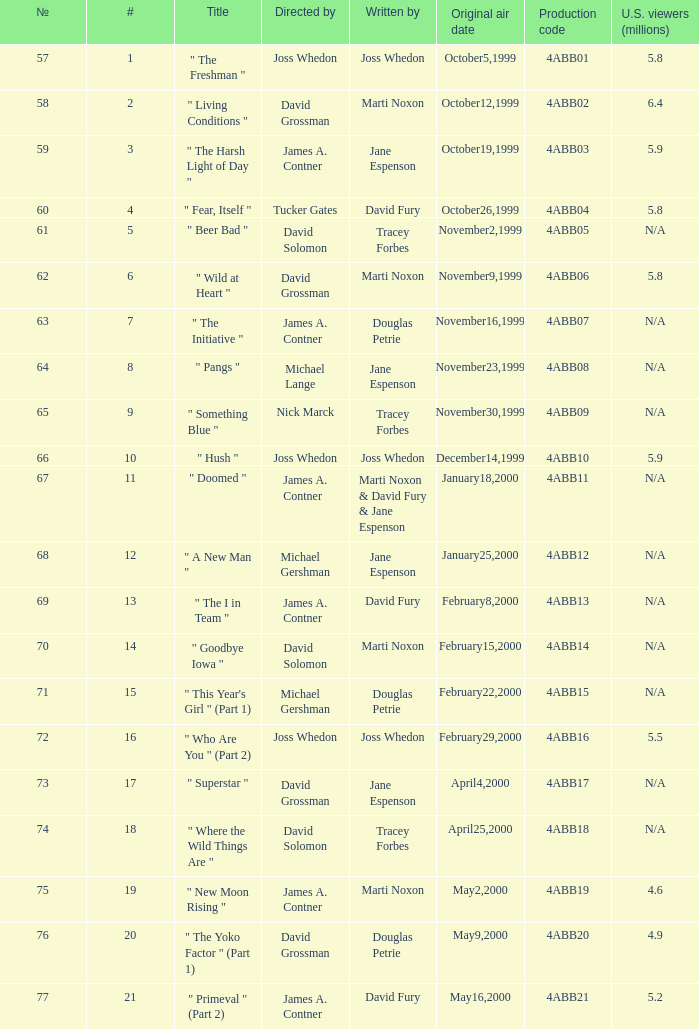What is the title of episode No. 65? " Something Blue ". 